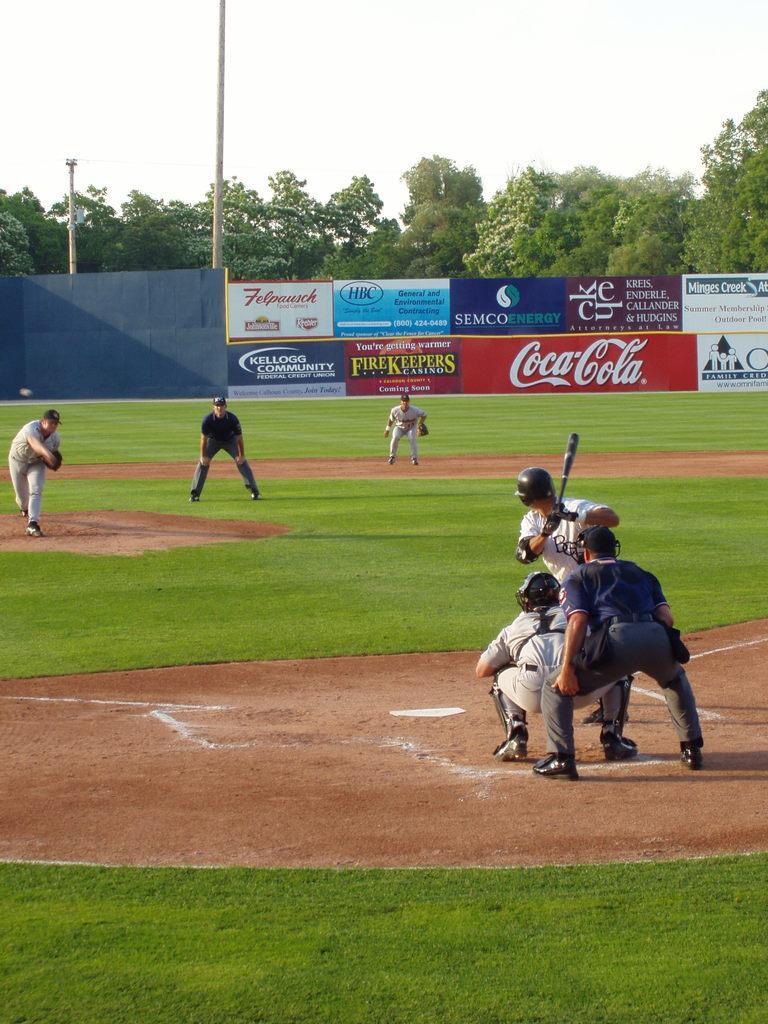Please provide a concise description of this image. In this image we can see persons standing on the ground. In the background there are advertisement boards, poles, trees and sky. 